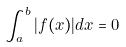<formula> <loc_0><loc_0><loc_500><loc_500>\int _ { a } ^ { b } | f ( x ) | d x = 0</formula> 